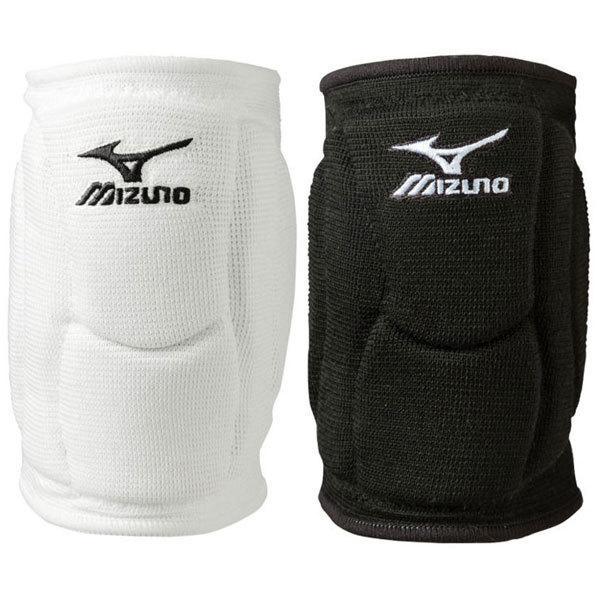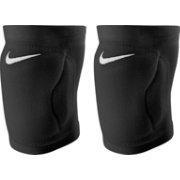The first image is the image on the left, the second image is the image on the right. Given the left and right images, does the statement "There are three black knee braces and one white knee brace." hold true? Answer yes or no. Yes. The first image is the image on the left, the second image is the image on the right. For the images displayed, is the sentence "Three of the four total knee pads are black" factually correct? Answer yes or no. Yes. The first image is the image on the left, the second image is the image on the right. For the images shown, is this caption "At least one pair of kneepads is worn by a human." true? Answer yes or no. No. The first image is the image on the left, the second image is the image on the right. Analyze the images presented: Is the assertion "One image shows one each of white and black knee pads." valid? Answer yes or no. Yes. 